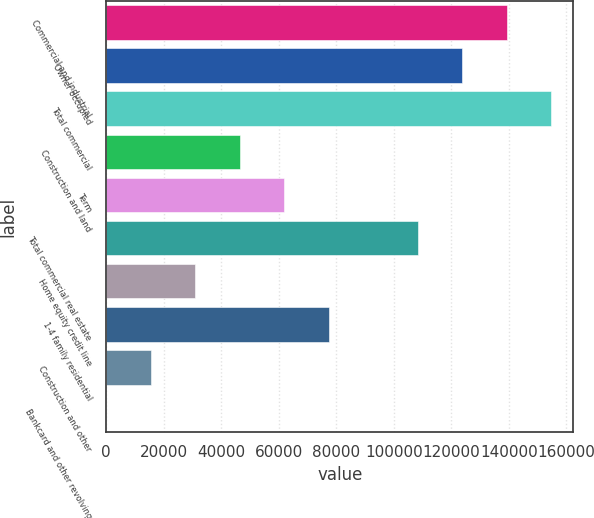Convert chart. <chart><loc_0><loc_0><loc_500><loc_500><bar_chart><fcel>Commercial and industrial<fcel>Owner occupied<fcel>Total commercial<fcel>Construction and land<fcel>Term<fcel>Total commercial real estate<fcel>Home equity credit line<fcel>1-4 family residential<fcel>Construction and other<fcel>Bankcard and other revolving<nl><fcel>139308<fcel>123838<fcel>154778<fcel>46489.4<fcel>61959.2<fcel>108369<fcel>31019.6<fcel>77429<fcel>15549.8<fcel>80<nl></chart> 